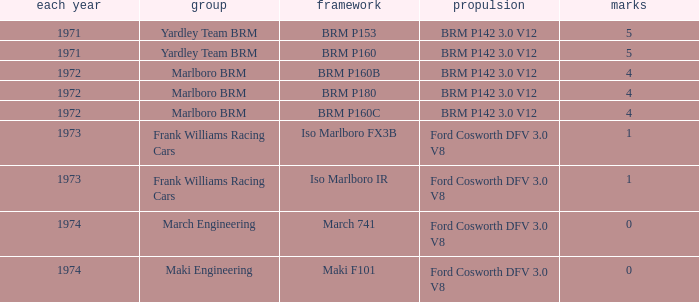Which chassis has marlboro brm as the team? BRM P160B, BRM P180, BRM P160C. 